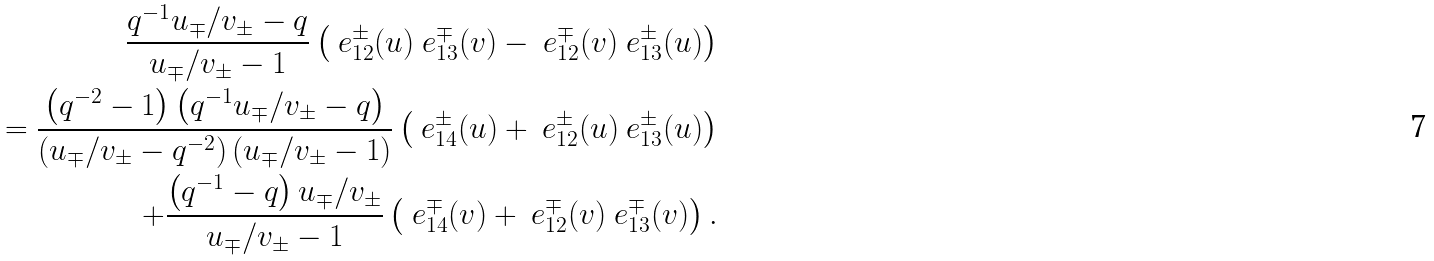<formula> <loc_0><loc_0><loc_500><loc_500>\frac { q ^ { - 1 } u _ { \mp } / v _ { \pm } - q } { u _ { \mp } / v _ { \pm } - 1 } \left ( \ e _ { 1 2 } ^ { \pm } ( u ) \ e _ { 1 3 } ^ { \mp } ( v ) - \ e _ { 1 2 } ^ { \mp } ( v ) \ e _ { 1 3 } ^ { \pm } ( u ) \right ) \\ = \frac { \left ( q ^ { - 2 } - 1 \right ) \left ( q ^ { - 1 } u _ { \mp } / v _ { \pm } - q \right ) } { \left ( u _ { \mp } / v _ { \pm } - q ^ { - 2 } \right ) \left ( u _ { \mp } / v _ { \pm } - 1 \right ) } \left ( \ e _ { 1 4 } ^ { \pm } ( u ) + \ e _ { 1 2 } ^ { \pm } ( u ) \ e _ { 1 3 } ^ { \pm } ( u ) \right ) \\ \quad + \frac { \left ( q ^ { - 1 } - q \right ) u _ { \mp } / v _ { \pm } } { u _ { \mp } / v _ { \pm } - 1 } \left ( \ e _ { 1 4 } ^ { \mp } ( v ) + \ e _ { 1 2 } ^ { \mp } ( v ) \ e _ { 1 3 } ^ { \mp } ( v ) \right ) .</formula> 